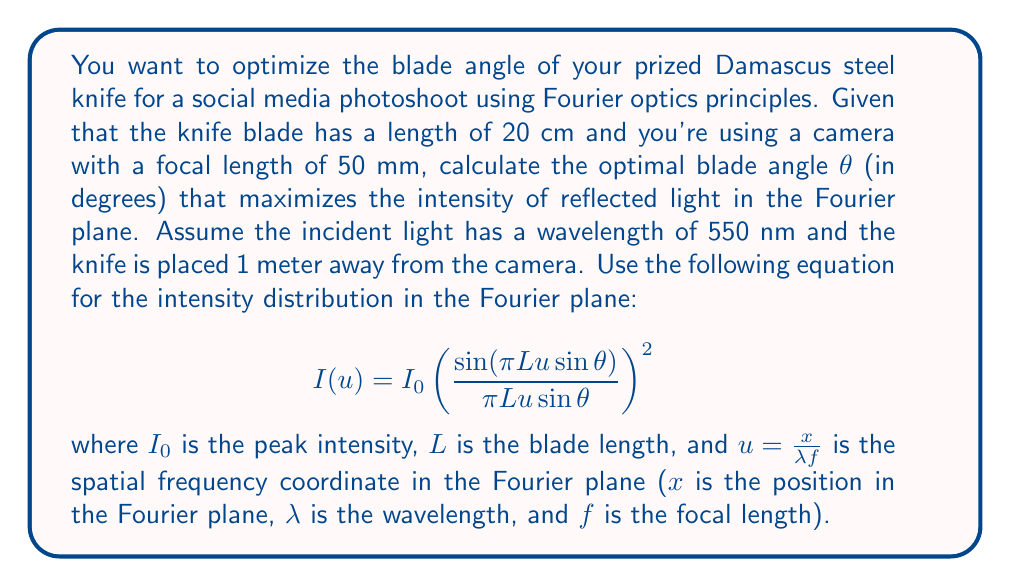Give your solution to this math problem. To solve this problem, we need to find the angle θ that maximizes the intensity distribution in the Fourier plane. The maximum intensity occurs when the sinc function in the equation reaches its peak value of 1, which happens when its argument is zero:

$$ \pi L u \sin θ = 0 $$

Since L, u, and π are non-zero, we need:

$$ \sin θ = 0 $$

This occurs when θ = 0°, 180°, 360°, etc. However, we need to consider the practical constraints of knife photography.

The most visually striking angle for a knife blade is typically when it reflects the maximum amount of light towards the camera. This occurs when the blade is perpendicular to the bisector of the angle between the incident light and the camera's line of sight.

Assuming the light source is positioned directly above the camera, we can calculate this optimal angle:

1. The distance from the knife to the camera is 1 meter.
2. The knife blade length is 20 cm (0.2 m).

We can visualize this as a right triangle:

[asy]
import geometry;

pair A = (0,0);
pair B = (100,0);
pair C = (100,20);

draw(A--B--C--A);

label("1 m", (50,0), S);
label("20 cm", (100,10), E);
label("θ", (5,3), NW);

draw(arc(A,5,0,atan2(20,100)), Arrow);
[/asy]

The optimal angle θ can be calculated using:

$$ θ = \frac{1}{2} \tan^{-1}\left(\frac{0.2}{1}\right) $$

$$ θ = \frac{1}{2} \tan^{-1}(0.2) $$

$$ θ ≈ 5.71° $$

This angle ensures that the maximum amount of light is reflected towards the camera, creating the most visually striking image for social media.
Answer: The optimal blade angle for social media photography using Fourier optics principles is approximately 5.71°. 